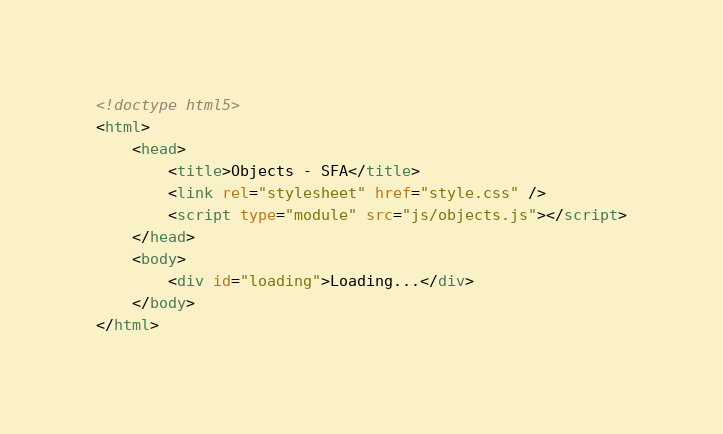Convert code to text. <code><loc_0><loc_0><loc_500><loc_500><_HTML_><!doctype html5>
<html>
    <head>
        <title>Objects - SFA</title>
        <link rel="stylesheet" href="style.css" />
        <script type="module" src="js/objects.js"></script>
    </head>
    <body>
        <div id="loading">Loading...</div>
    </body>
</html>
</code> 